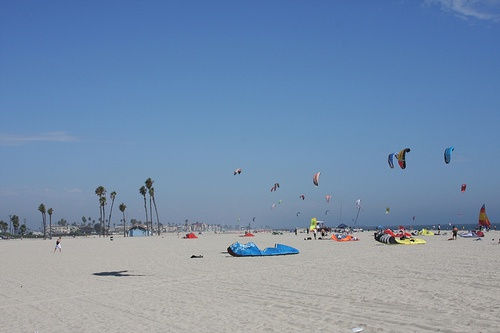Describe the objects in this image and their specific colors. I can see kite in blue and gray tones, boat in blue, gray, black, and lightblue tones, kite in blue, maroon, gray, olive, and black tones, kite in blue, black, gray, olive, and maroon tones, and kite in blue, teal, and gray tones in this image. 